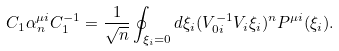Convert formula to latex. <formula><loc_0><loc_0><loc_500><loc_500>C _ { 1 } \alpha _ { n } ^ { \mu i } C _ { 1 } ^ { - 1 } = \frac { 1 } { \sqrt { n } } \oint _ { \xi _ { i } = 0 } d \xi _ { i } ( V _ { 0 i } ^ { - 1 } V _ { i } \xi _ { i } ) ^ { n } P ^ { \mu i } ( \xi _ { i } ) .</formula> 